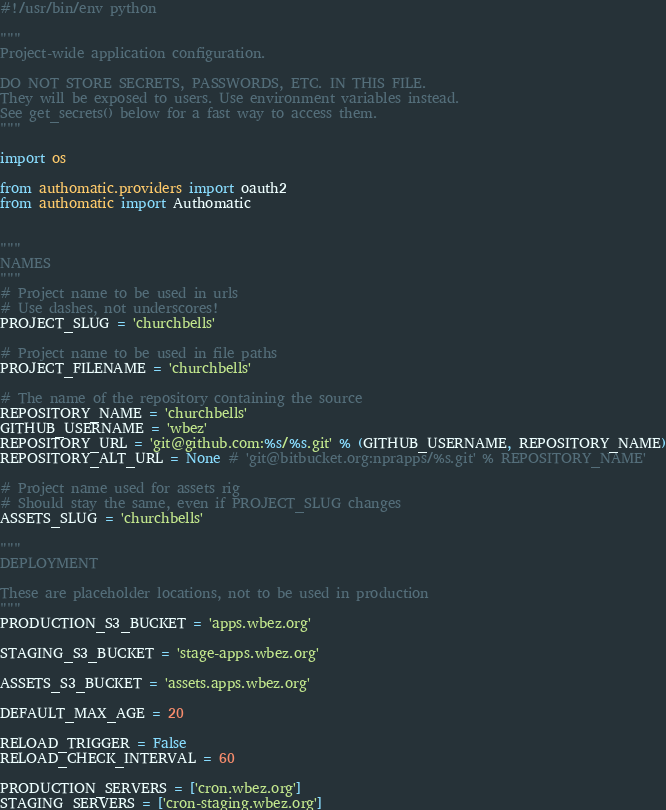<code> <loc_0><loc_0><loc_500><loc_500><_Python_>#!/usr/bin/env python

"""
Project-wide application configuration.

DO NOT STORE SECRETS, PASSWORDS, ETC. IN THIS FILE.
They will be exposed to users. Use environment variables instead.
See get_secrets() below for a fast way to access them.
"""

import os

from authomatic.providers import oauth2
from authomatic import Authomatic


"""
NAMES
"""
# Project name to be used in urls
# Use dashes, not underscores!
PROJECT_SLUG = 'churchbells'

# Project name to be used in file paths
PROJECT_FILENAME = 'churchbells'

# The name of the repository containing the source
REPOSITORY_NAME = 'churchbells'
GITHUB_USERNAME = 'wbez'
REPOSITORY_URL = 'git@github.com:%s/%s.git' % (GITHUB_USERNAME, REPOSITORY_NAME)
REPOSITORY_ALT_URL = None # 'git@bitbucket.org:nprapps/%s.git' % REPOSITORY_NAME'

# Project name used for assets rig
# Should stay the same, even if PROJECT_SLUG changes
ASSETS_SLUG = 'churchbells'

"""
DEPLOYMENT

These are placeholder locations, not to be used in production
"""
PRODUCTION_S3_BUCKET = 'apps.wbez.org'

STAGING_S3_BUCKET = 'stage-apps.wbez.org'

ASSETS_S3_BUCKET = 'assets.apps.wbez.org'

DEFAULT_MAX_AGE = 20

RELOAD_TRIGGER = False
RELOAD_CHECK_INTERVAL = 60

PRODUCTION_SERVERS = ['cron.wbez.org']
STAGING_SERVERS = ['cron-staging.wbez.org']
</code> 